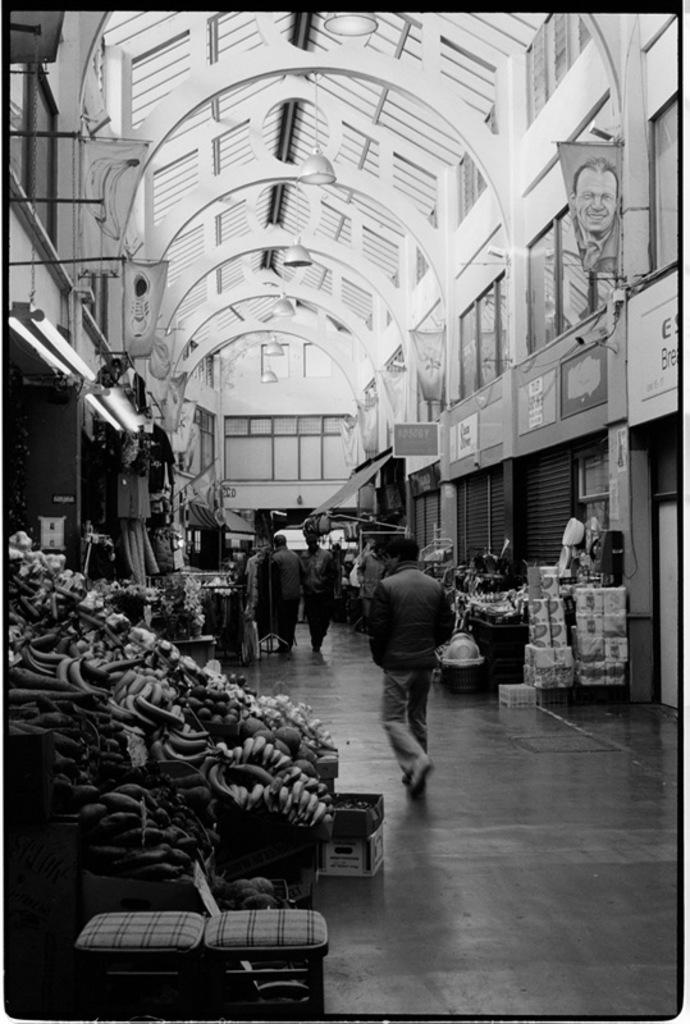What is the color scheme of the image? The image is black and white. What types of subjects are present in the image? There are people, boxes, lights, a roof, banners, boards, shutters, fruits, and stools in the image. Can you describe the floor in the image? There is a floor in the image. What other objects can be seen in the image? There are other objects in the image, but their specific details are not mentioned in the provided facts. What type of glove is being used to serve the cheese in the image? There is no glove or cheese present in the image. What type of plate is being used to serve the cheese in the glove is holding in the image? There is no glove, cheese, or plate present in the image. 